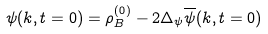<formula> <loc_0><loc_0><loc_500><loc_500>\psi ( k , t = 0 ) = \rho _ { B } ^ { ( 0 ) } - 2 \Delta _ { \psi } \overline { \psi } ( k , t = 0 )</formula> 